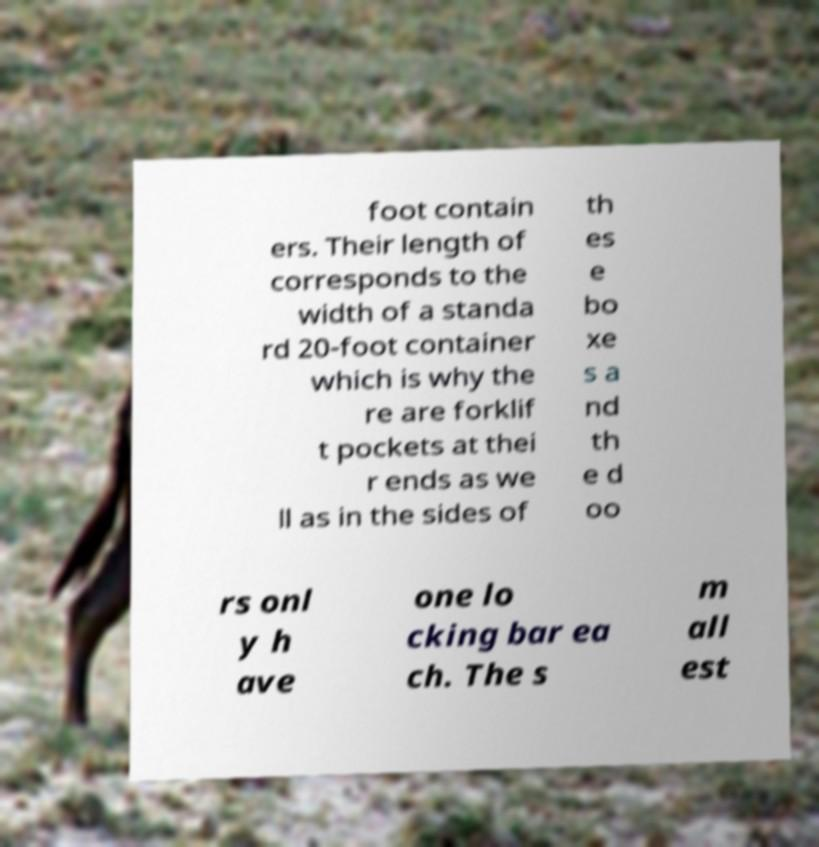Please read and relay the text visible in this image. What does it say? foot contain ers. Their length of corresponds to the width of a standa rd 20-foot container which is why the re are forklif t pockets at thei r ends as we ll as in the sides of th es e bo xe s a nd th e d oo rs onl y h ave one lo cking bar ea ch. The s m all est 